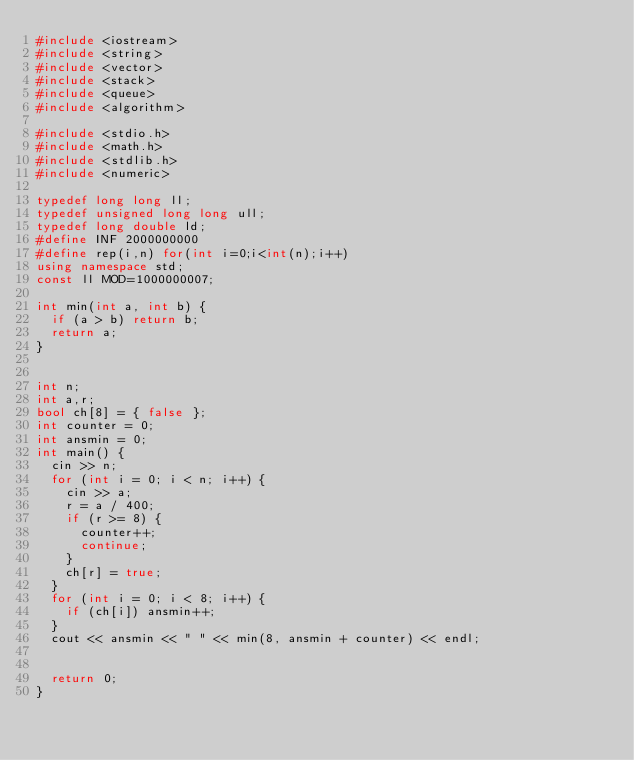<code> <loc_0><loc_0><loc_500><loc_500><_C++_>#include <iostream>
#include <string>
#include <vector>
#include <stack>
#include <queue>
#include <algorithm>

#include <stdio.h>
#include <math.h>
#include <stdlib.h>
#include <numeric>

typedef long long ll;
typedef unsigned long long ull;
typedef long double ld;
#define INF 2000000000
#define rep(i,n) for(int i=0;i<int(n);i++)
using namespace std;
const ll MOD=1000000007;

int min(int a, int b) {
	if (a > b) return b;
	return a;
}


int n;
int a,r;
bool ch[8] = { false };
int counter = 0;
int ansmin = 0;
int main() {
	cin >> n;
	for (int i = 0; i < n; i++) {
		cin >> a;
		r = a / 400;
		if (r >= 8) {
			counter++;
			continue;
		}
		ch[r] = true;
	}
	for (int i = 0; i < 8; i++) {
		if (ch[i]) ansmin++;
	}
	cout << ansmin << " " << min(8, ansmin + counter) << endl;


	return 0;
}</code> 